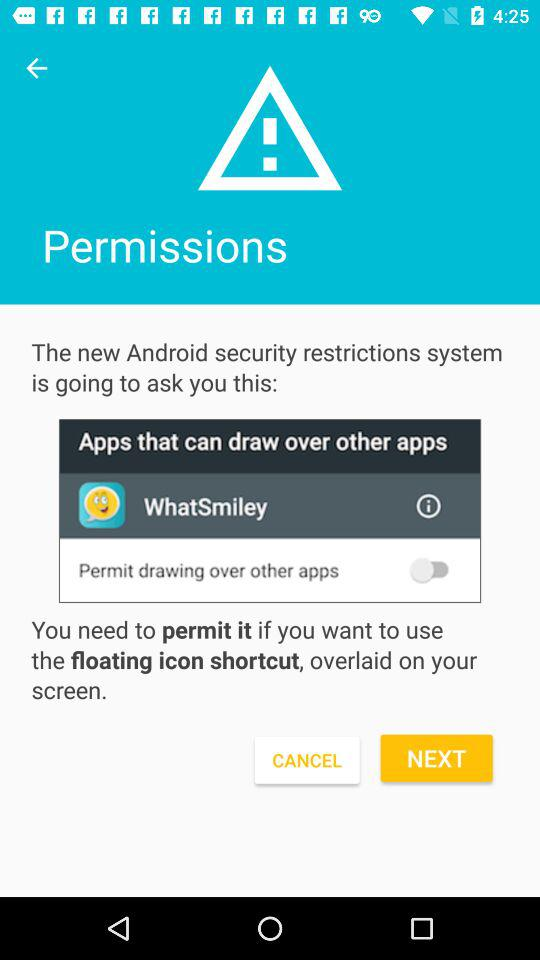How many apps can draw over other apps?
Answer the question using a single word or phrase. 1 